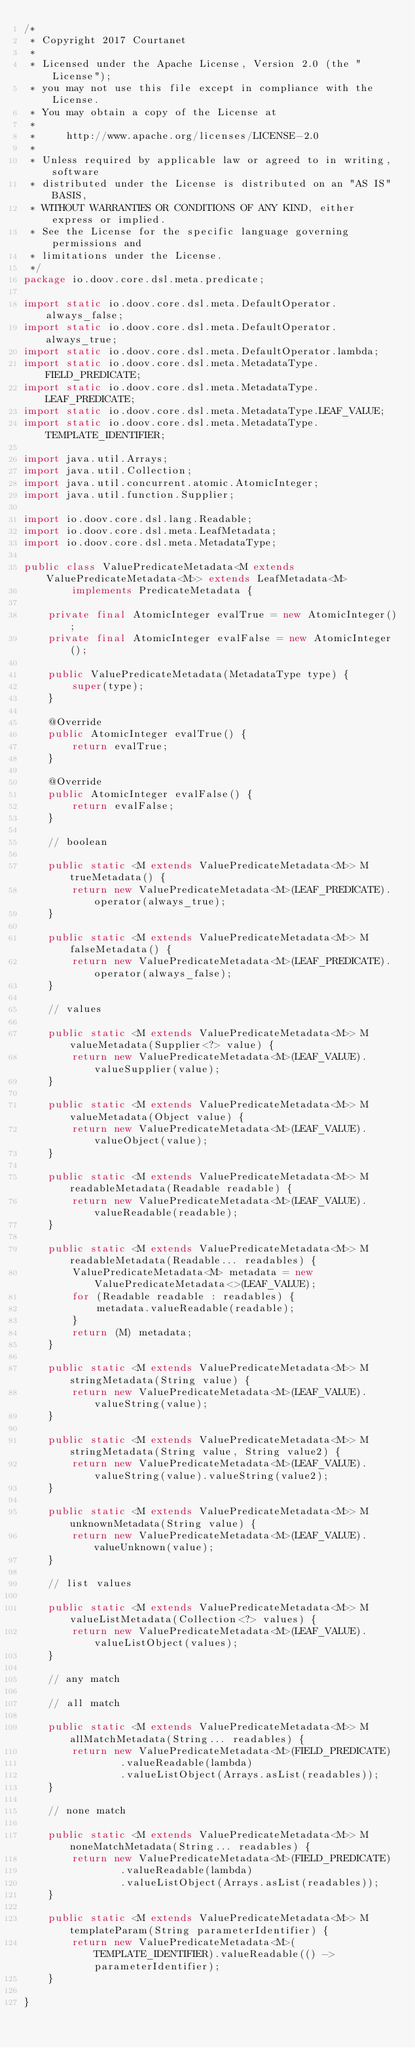Convert code to text. <code><loc_0><loc_0><loc_500><loc_500><_Java_>/*
 * Copyright 2017 Courtanet
 *
 * Licensed under the Apache License, Version 2.0 (the "License");
 * you may not use this file except in compliance with the License.
 * You may obtain a copy of the License at
 *
 *     http://www.apache.org/licenses/LICENSE-2.0
 *
 * Unless required by applicable law or agreed to in writing, software
 * distributed under the License is distributed on an "AS IS" BASIS,
 * WITHOUT WARRANTIES OR CONDITIONS OF ANY KIND, either express or implied.
 * See the License for the specific language governing permissions and
 * limitations under the License.
 */
package io.doov.core.dsl.meta.predicate;

import static io.doov.core.dsl.meta.DefaultOperator.always_false;
import static io.doov.core.dsl.meta.DefaultOperator.always_true;
import static io.doov.core.dsl.meta.DefaultOperator.lambda;
import static io.doov.core.dsl.meta.MetadataType.FIELD_PREDICATE;
import static io.doov.core.dsl.meta.MetadataType.LEAF_PREDICATE;
import static io.doov.core.dsl.meta.MetadataType.LEAF_VALUE;
import static io.doov.core.dsl.meta.MetadataType.TEMPLATE_IDENTIFIER;

import java.util.Arrays;
import java.util.Collection;
import java.util.concurrent.atomic.AtomicInteger;
import java.util.function.Supplier;

import io.doov.core.dsl.lang.Readable;
import io.doov.core.dsl.meta.LeafMetadata;
import io.doov.core.dsl.meta.MetadataType;

public class ValuePredicateMetadata<M extends ValuePredicateMetadata<M>> extends LeafMetadata<M>
        implements PredicateMetadata {

    private final AtomicInteger evalTrue = new AtomicInteger();
    private final AtomicInteger evalFalse = new AtomicInteger();

    public ValuePredicateMetadata(MetadataType type) {
        super(type);
    }

    @Override
    public AtomicInteger evalTrue() {
        return evalTrue;
    }

    @Override
    public AtomicInteger evalFalse() {
        return evalFalse;
    }

    // boolean

    public static <M extends ValuePredicateMetadata<M>> M trueMetadata() {
        return new ValuePredicateMetadata<M>(LEAF_PREDICATE).operator(always_true);
    }

    public static <M extends ValuePredicateMetadata<M>> M falseMetadata() {
        return new ValuePredicateMetadata<M>(LEAF_PREDICATE).operator(always_false);
    }

    // values

    public static <M extends ValuePredicateMetadata<M>> M valueMetadata(Supplier<?> value) {
        return new ValuePredicateMetadata<M>(LEAF_VALUE).valueSupplier(value);
    }

    public static <M extends ValuePredicateMetadata<M>> M valueMetadata(Object value) {
        return new ValuePredicateMetadata<M>(LEAF_VALUE).valueObject(value);
    }

    public static <M extends ValuePredicateMetadata<M>> M readableMetadata(Readable readable) {
        return new ValuePredicateMetadata<M>(LEAF_VALUE).valueReadable(readable);
    }

    public static <M extends ValuePredicateMetadata<M>> M readableMetadata(Readable... readables) {
        ValuePredicateMetadata<M> metadata = new ValuePredicateMetadata<>(LEAF_VALUE);
        for (Readable readable : readables) {
            metadata.valueReadable(readable);
        }
        return (M) metadata;
    }

    public static <M extends ValuePredicateMetadata<M>> M stringMetadata(String value) {
        return new ValuePredicateMetadata<M>(LEAF_VALUE).valueString(value);
    }

    public static <M extends ValuePredicateMetadata<M>> M stringMetadata(String value, String value2) {
        return new ValuePredicateMetadata<M>(LEAF_VALUE).valueString(value).valueString(value2);
    }

    public static <M extends ValuePredicateMetadata<M>> M unknownMetadata(String value) {
        return new ValuePredicateMetadata<M>(LEAF_VALUE).valueUnknown(value);
    }

    // list values

    public static <M extends ValuePredicateMetadata<M>> M valueListMetadata(Collection<?> values) {
        return new ValuePredicateMetadata<M>(LEAF_VALUE).valueListObject(values);
    }

    // any match

    // all match

    public static <M extends ValuePredicateMetadata<M>> M allMatchMetadata(String... readables) {
        return new ValuePredicateMetadata<M>(FIELD_PREDICATE)
                .valueReadable(lambda)
                .valueListObject(Arrays.asList(readables));
    }

    // none match

    public static <M extends ValuePredicateMetadata<M>> M noneMatchMetadata(String... readables) {
        return new ValuePredicateMetadata<M>(FIELD_PREDICATE)
                .valueReadable(lambda)
                .valueListObject(Arrays.asList(readables));
    }

    public static <M extends ValuePredicateMetadata<M>> M templateParam(String parameterIdentifier) {
        return new ValuePredicateMetadata<M>(TEMPLATE_IDENTIFIER).valueReadable(() -> parameterIdentifier);
    }

}
</code> 